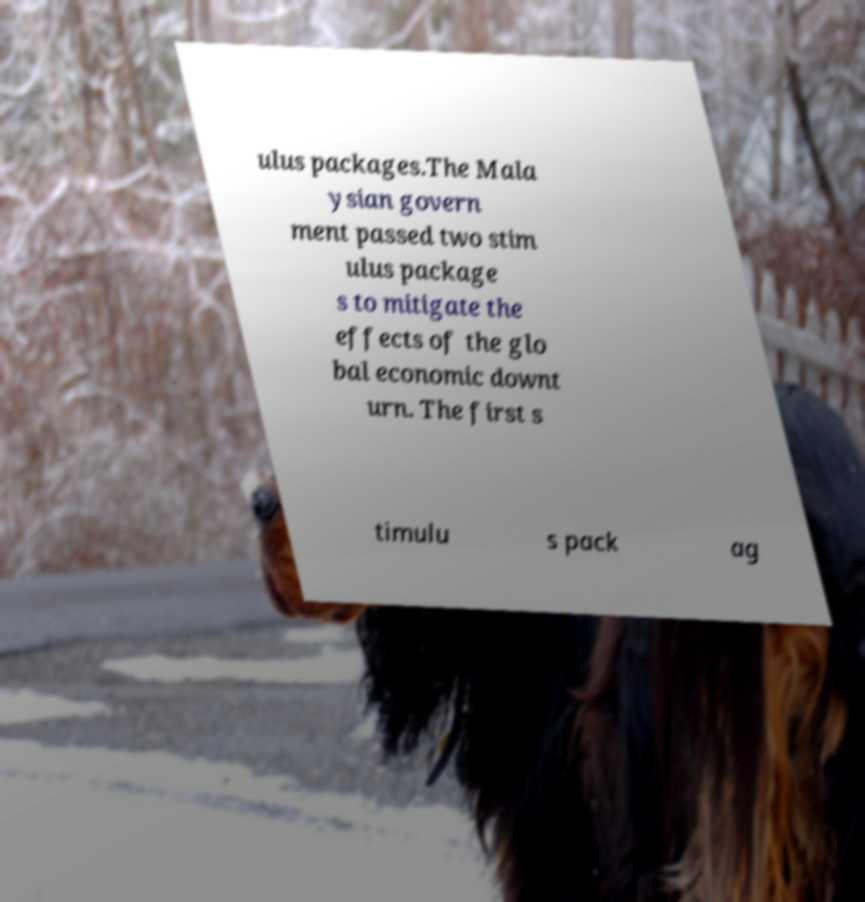Please read and relay the text visible in this image. What does it say? ulus packages.The Mala ysian govern ment passed two stim ulus package s to mitigate the effects of the glo bal economic downt urn. The first s timulu s pack ag 